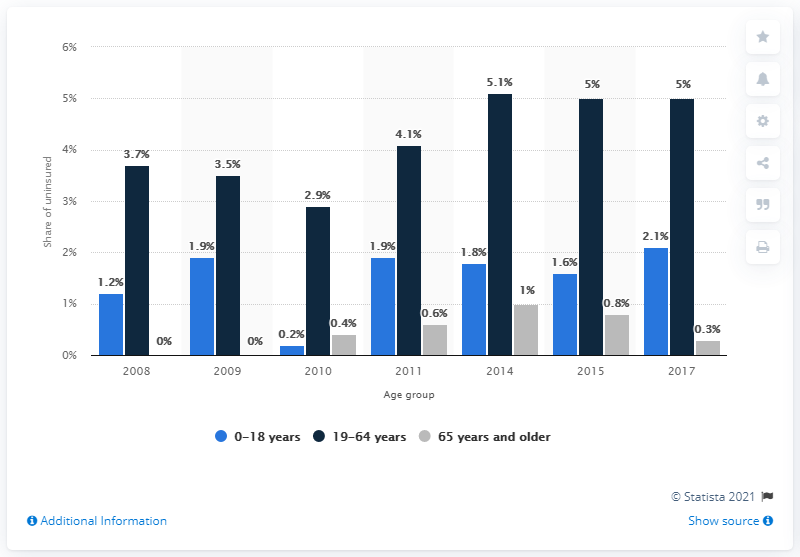Give some essential details in this illustration. In 2014, 1.8% of individuals aged 0-18 years lacked health insurance coverage. 